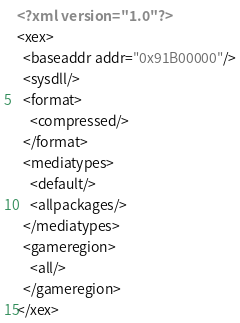<code> <loc_0><loc_0><loc_500><loc_500><_XML_><?xml version="1.0"?>
<xex>
  <baseaddr addr="0x91B00000"/>
  <sysdll/>
  <format>
    <compressed/>
  </format>
  <mediatypes>
    <default/>
    <allpackages/>
  </mediatypes>
  <gameregion>
    <all/>
  </gameregion>
</xex></code> 